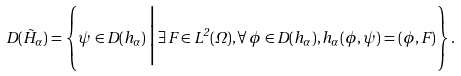Convert formula to latex. <formula><loc_0><loc_0><loc_500><loc_500>D ( \tilde { H } _ { \alpha } ) = \left \{ \psi \in D ( h _ { \alpha } ) \, \Big | \, \exists \, F \in L ^ { 2 } ( \Omega ) , \forall \, \phi \in D ( h _ { \alpha } ) , h _ { \alpha } ( \phi , \psi ) = ( \phi , F ) \right \} .</formula> 